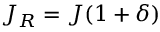Convert formula to latex. <formula><loc_0><loc_0><loc_500><loc_500>J _ { R } = J ( 1 + \delta )</formula> 